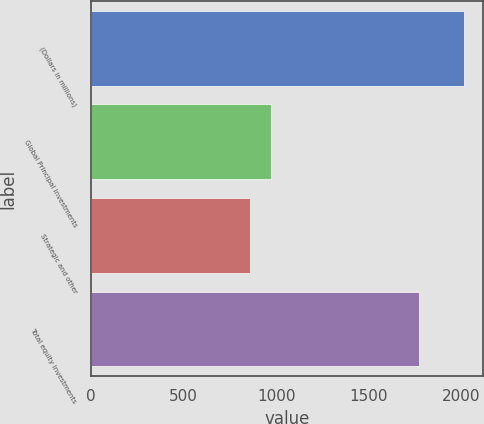<chart> <loc_0><loc_0><loc_500><loc_500><bar_chart><fcel>(Dollars in millions)<fcel>Global Principal Investments<fcel>Strategic and other<fcel>Total equity investments<nl><fcel>2014<fcel>973.6<fcel>858<fcel>1770<nl></chart> 